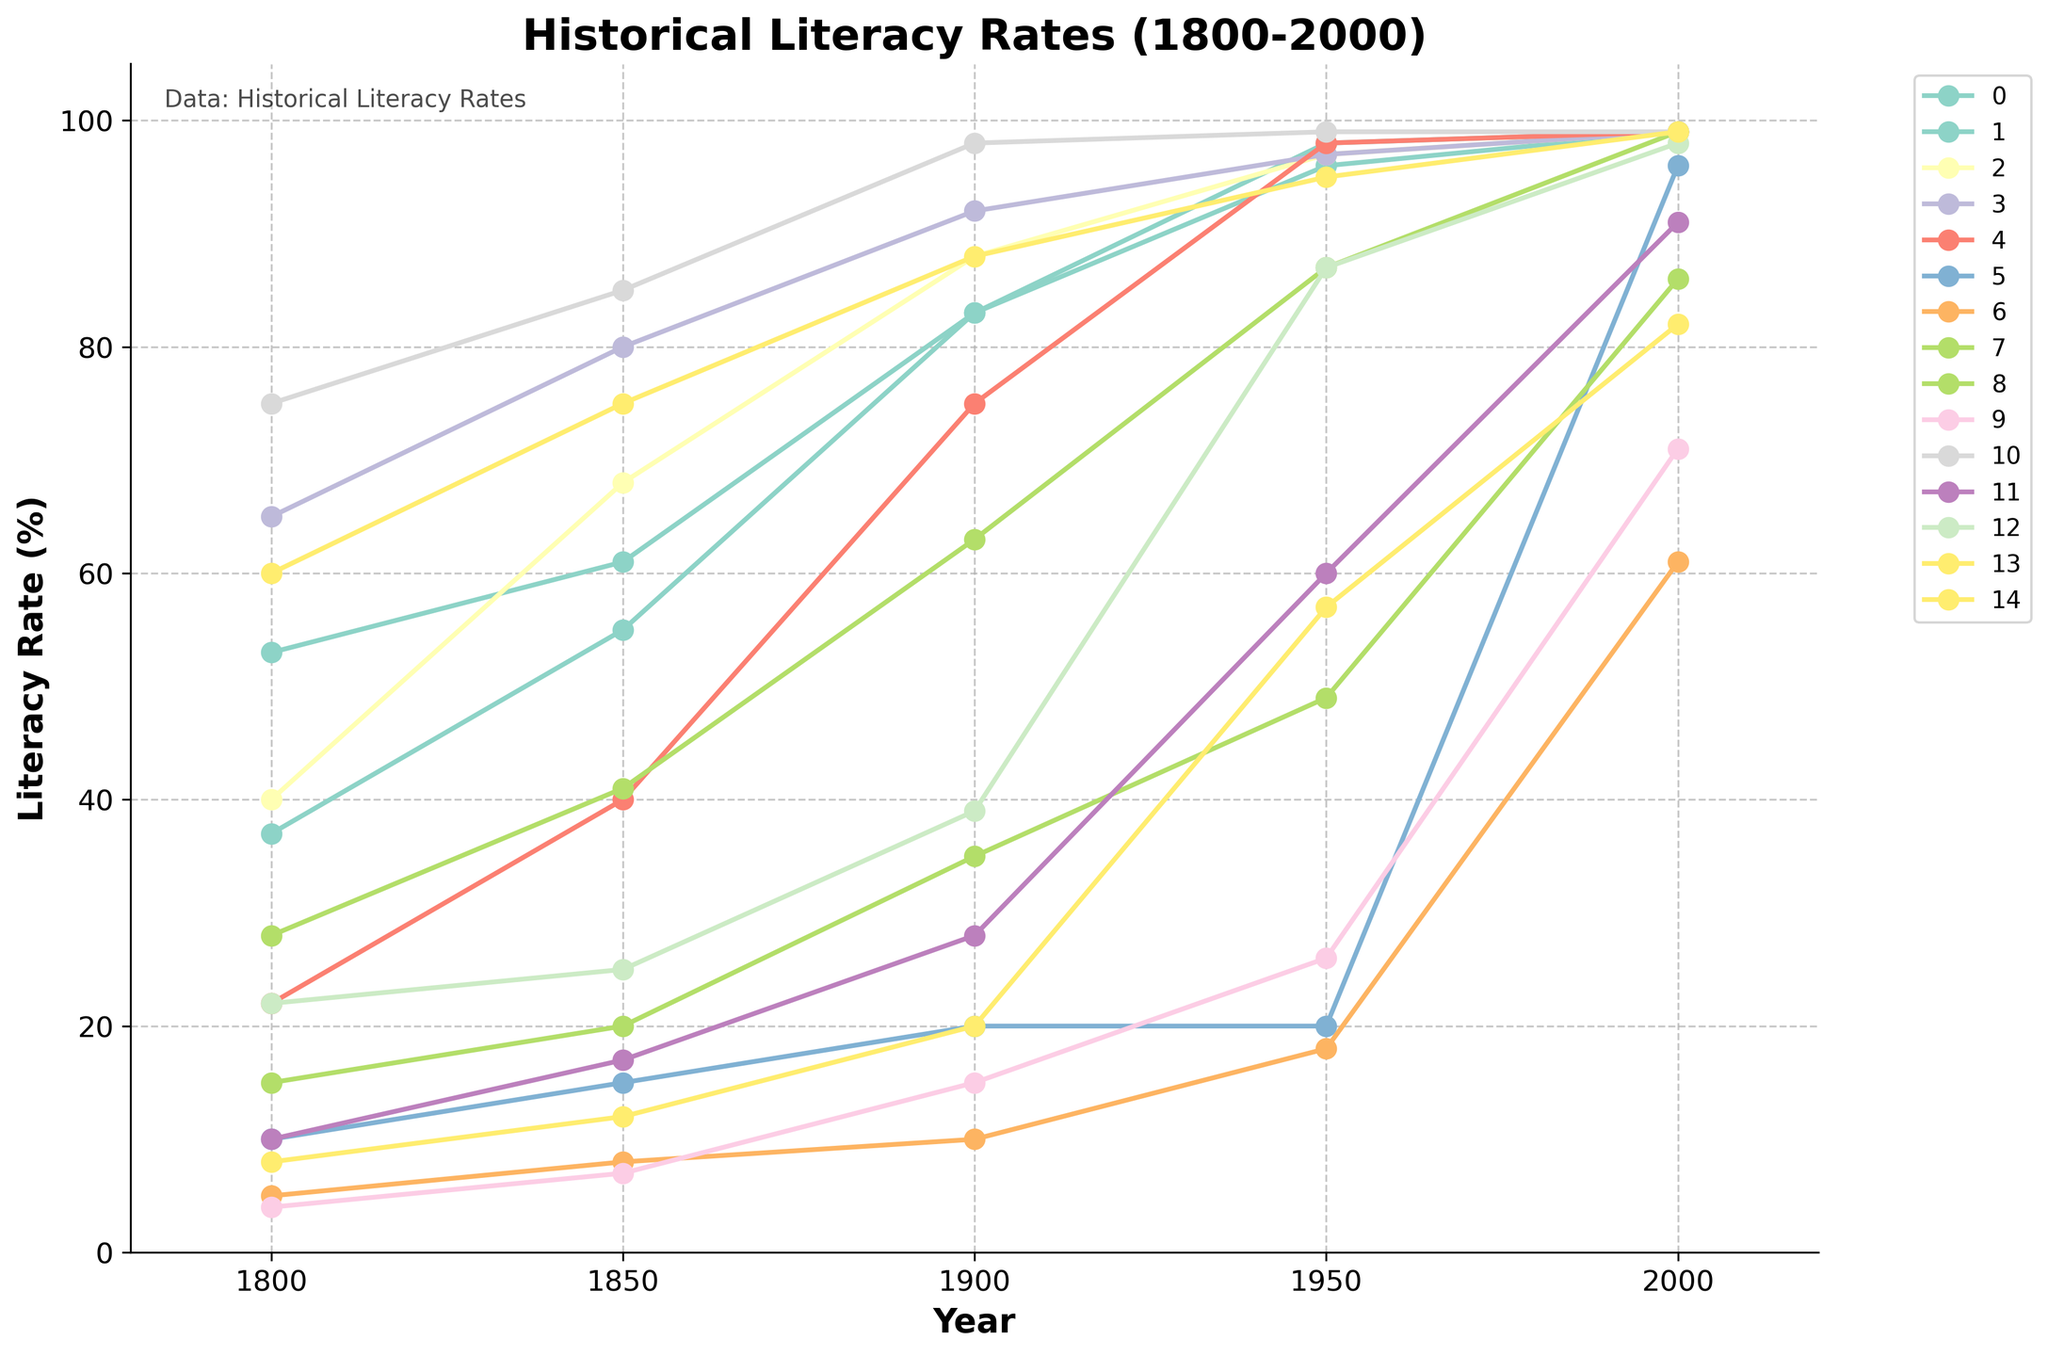What's the difference in literacy rates between Japan and Brazil in 1900? In 1900, Japan's literacy rate was 75%, and Brazil's was 35%. The difference is calculated by subtracting Brazil's rate from Japan's rate (75 - 35).
Answer: 40% Which country had the highest literacy rate in 1800? By comparing the literacy rates in 1800 for all the countries, the United States had a 65% literacy rate which is the highest.
Answer: United States How much did the literacy rate increase in India from 1800 to 2000? India's literacy rate was 5% in 1800 and 61% in 2000. The increase is calculated by subtracting the 1800 rate from the 2000 rate (61 - 5).
Answer: 56% Between which two years did China see the largest increase in literacy rate? By examining the increment values at each transition year, the largest increase in China’s literacy rate happened between 1950 (20%) and 2000 (96%), which is computed as (96 - 20).
Answer: 1950 to 2000 In 1950, which countries had a literacy rate equal to or above 90%? Reviewing the 1950 literacy rates, United Kingdom, United States, and Sweden all had literacy rates of 98%, 97%, and 99% respectively, which are equal to or above 90%.
Answer: United Kingdom, United States, Sweden How did the literacy rate in Egypt change between 1900 and 1950, and 1950 and 2000? Egypt's literacy rates are 15% in 1900, 26% in 1950, and 71% in 2000. The increase from 1900 to 1950 is (26 - 15) = 11%. The increase from 1950 to 2000 is (71 - 26) = 45%.
Answer: 11% and 45% Which country had the slowest growth in literacy rate from 1800 to 1850? By comparing the growth in literacy rates for each country between 1800 and 1850, India had the smallest increase, growing from 5% to 8%, which is a 3% increase.
Answer: India What was the average literacy rate of France across the years provided? The literacy rates for France are 37, 55, 83, 96, and 99. The average is calculated by summing these values and dividing by the number of years. Thus, (37 + 55 + 83 + 96 + 99) / 5 = 370 / 5.
Answer: 74% Which country showed the largest literacy rate gain from 1900 to 2000? From 1900 to 2000, China had the largest gain, increasing from 20% to 96%, so the gain is (96 - 20).
Answer: China By what percentage did the literacy rate in Russia increase from 1900 to 1950? Russia's literacy rates were 63% in 1900 and 87% in 1950. The increase is (87 - 63), and the percentage increase is calculated by (24 / 63) * 100.
Answer: 38% 